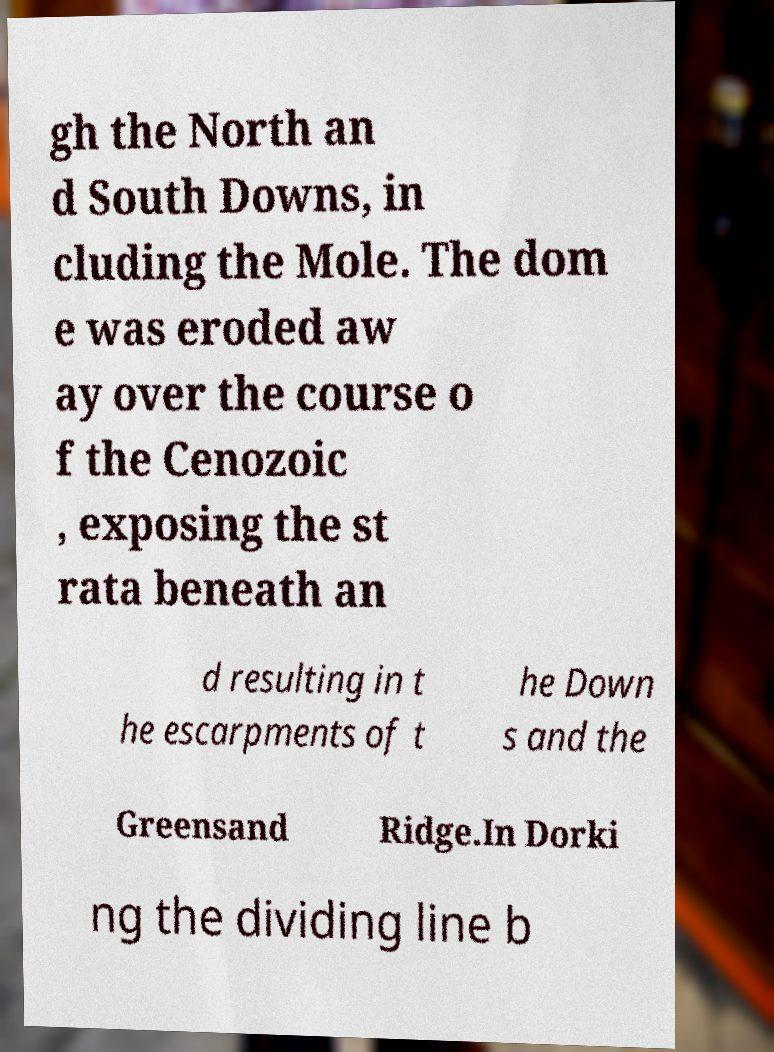What messages or text are displayed in this image? I need them in a readable, typed format. gh the North an d South Downs, in cluding the Mole. The dom e was eroded aw ay over the course o f the Cenozoic , exposing the st rata beneath an d resulting in t he escarpments of t he Down s and the Greensand Ridge.In Dorki ng the dividing line b 